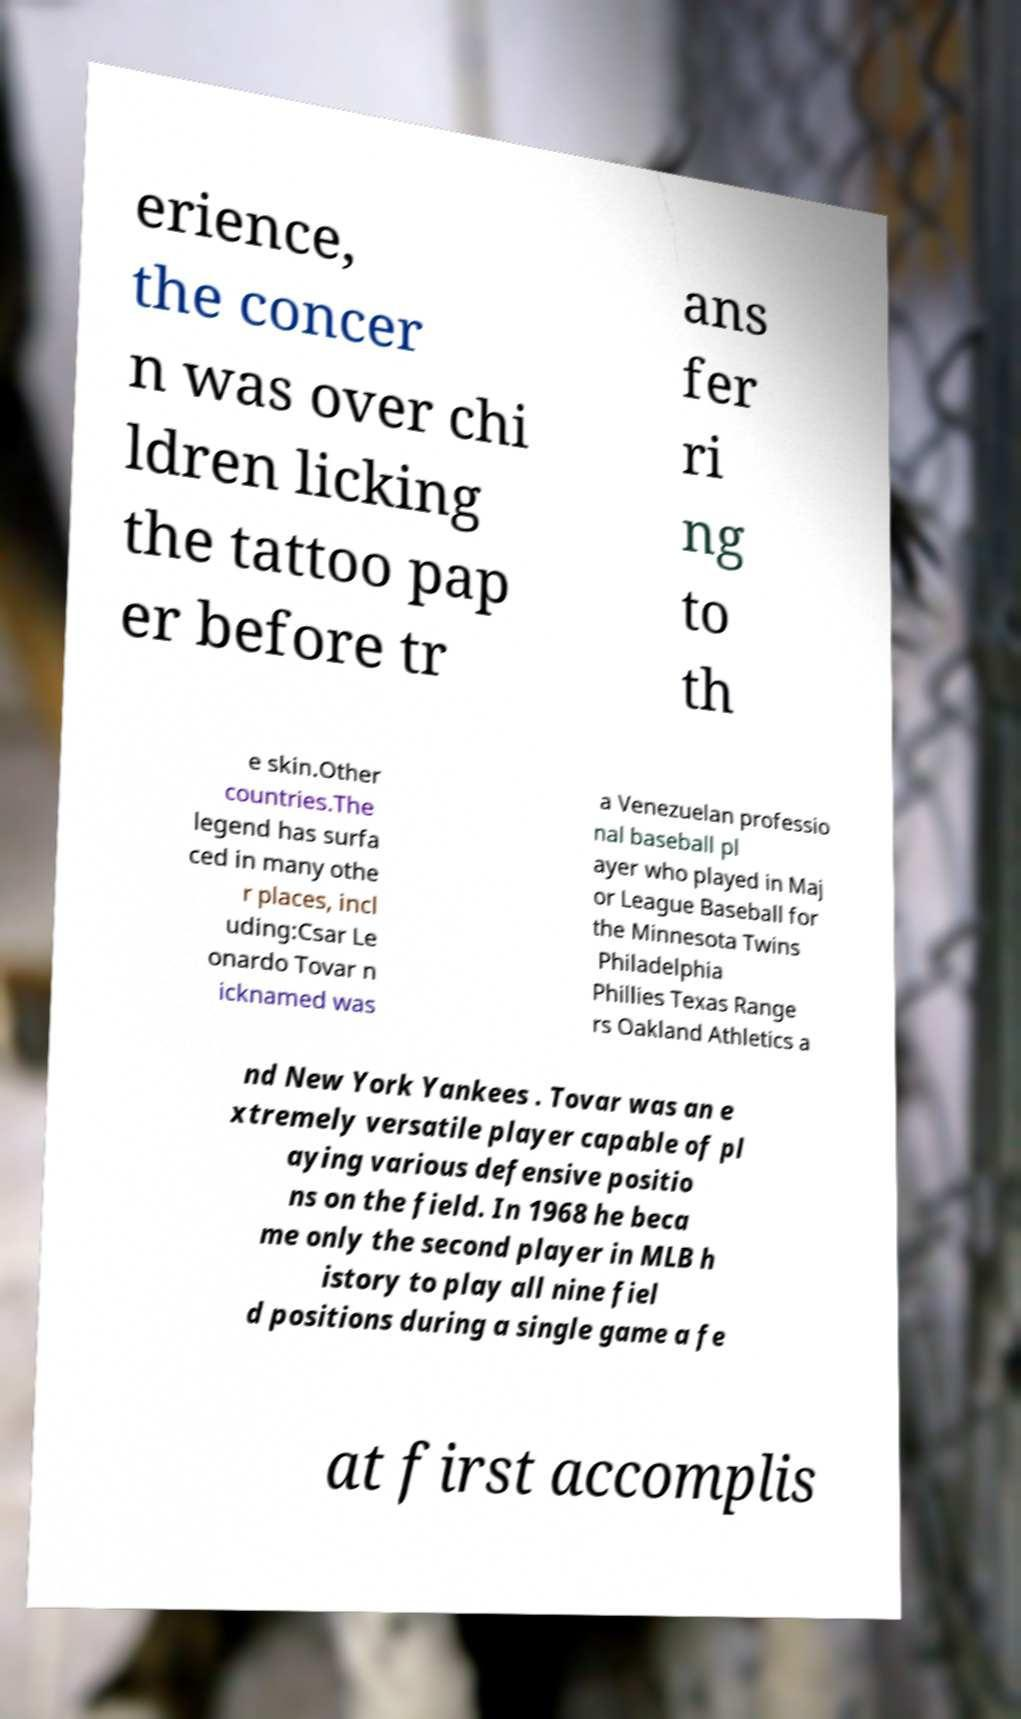There's text embedded in this image that I need extracted. Can you transcribe it verbatim? erience, the concer n was over chi ldren licking the tattoo pap er before tr ans fer ri ng to th e skin.Other countries.The legend has surfa ced in many othe r places, incl uding:Csar Le onardo Tovar n icknamed was a Venezuelan professio nal baseball pl ayer who played in Maj or League Baseball for the Minnesota Twins Philadelphia Phillies Texas Range rs Oakland Athletics a nd New York Yankees . Tovar was an e xtremely versatile player capable of pl aying various defensive positio ns on the field. In 1968 he beca me only the second player in MLB h istory to play all nine fiel d positions during a single game a fe at first accomplis 